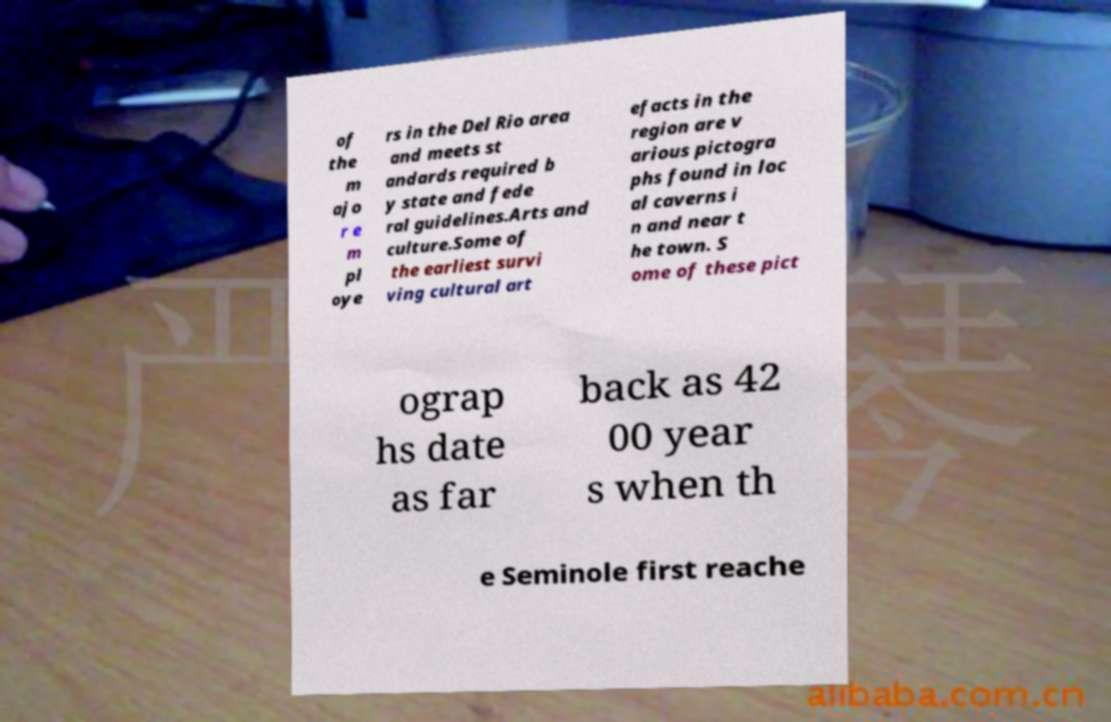Can you accurately transcribe the text from the provided image for me? of the m ajo r e m pl oye rs in the Del Rio area and meets st andards required b y state and fede ral guidelines.Arts and culture.Some of the earliest survi ving cultural art efacts in the region are v arious pictogra phs found in loc al caverns i n and near t he town. S ome of these pict ograp hs date as far back as 42 00 year s when th e Seminole first reache 